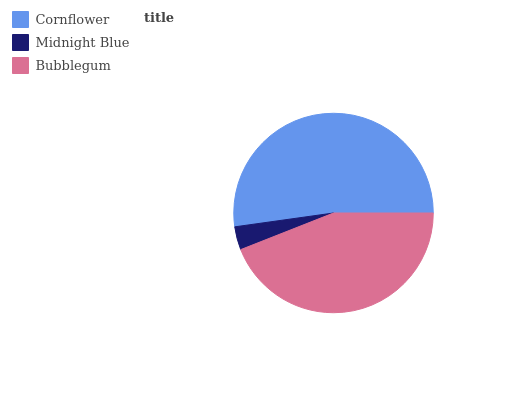Is Midnight Blue the minimum?
Answer yes or no. Yes. Is Cornflower the maximum?
Answer yes or no. Yes. Is Bubblegum the minimum?
Answer yes or no. No. Is Bubblegum the maximum?
Answer yes or no. No. Is Bubblegum greater than Midnight Blue?
Answer yes or no. Yes. Is Midnight Blue less than Bubblegum?
Answer yes or no. Yes. Is Midnight Blue greater than Bubblegum?
Answer yes or no. No. Is Bubblegum less than Midnight Blue?
Answer yes or no. No. Is Bubblegum the high median?
Answer yes or no. Yes. Is Bubblegum the low median?
Answer yes or no. Yes. Is Cornflower the high median?
Answer yes or no. No. Is Midnight Blue the low median?
Answer yes or no. No. 